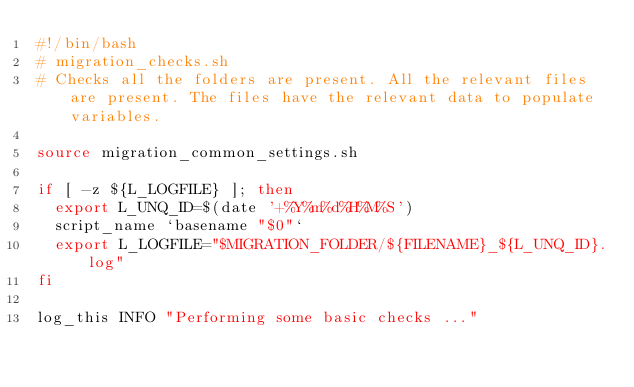Convert code to text. <code><loc_0><loc_0><loc_500><loc_500><_Bash_>#!/bin/bash
# migration_checks.sh
# Checks all the folders are present. All the relevant files are present. The files have the relevant data to populate variables.

source migration_common_settings.sh

if [ -z ${L_LOGFILE} ]; then
  export L_UNQ_ID=$(date '+%Y%m%d%H%M%S')
  script_name `basename "$0"`
  export L_LOGFILE="$MIGRATION_FOLDER/${FILENAME}_${L_UNQ_ID}.log"
fi 

log_this INFO "Performing some basic checks ..."
</code> 